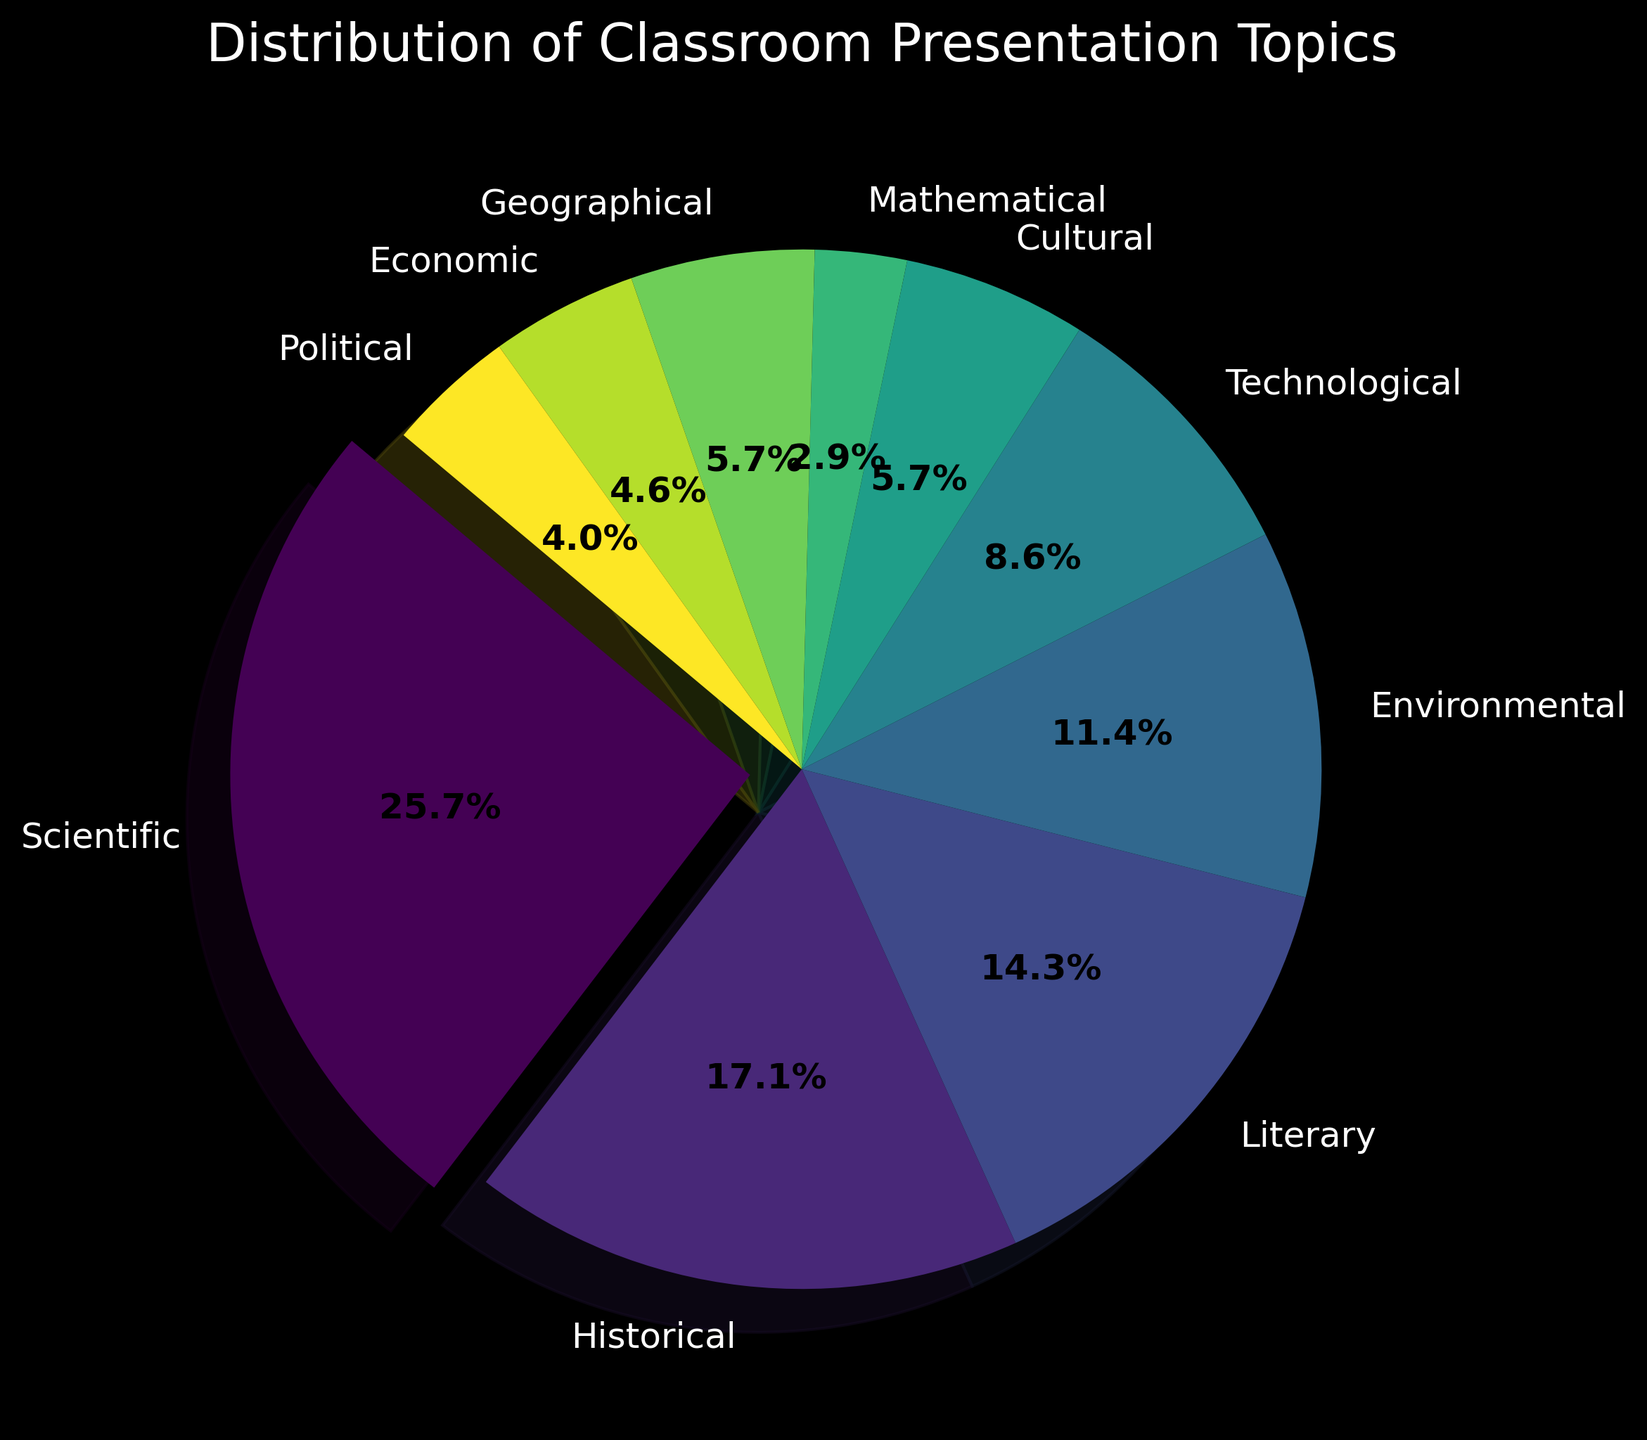What percentage of presentation topics are Scientific? The figure shows the distribution of presentation topics as a pie chart, with labels indicating the percentage. By looking at the Scientific portion of the pie chart, which is exploded for emphasis, we can see it represents 25%
Answer: 25% How does the number of Historical topics compare to Political topics? To find the answer, we compare the size of the slices representing Historical and Political topics. The Historical slice is significantly larger than the Political slice. The counts are 30 for Historical and 7 for Political.
Answer: Historical topics are more than Political topics Which topic is represented by the smallest slice? By examining the pie chart, the smallest slice can be identified visually. The slice for Mathematical topics is the smallest, with a count of 5.
Answer: Mathematical How many more Scientific topics are there compared to Environmental topics? From the figure, we know there are 45 Scientific topics and 20 Environmental topics. By subtracting the count for Environmental from that for Scientific (45 - 20), we get the difference.
Answer: 25 What is the total percentage of Cultural, Geographical, and Economic topics combined? We need to sum the percentages for Cultural, Geographical, and Economic topics from the pie chart: Cultural (5%), Geographical (5%), and Economic (4%). Adding these percentages together (5% + 5% + 4%) gives us the total.
Answer: 14% What percentage of the topics are Environmental? By looking at the pie chart segment labeled "Environmental", we can see the percentage indicated for this topic. It represents 11.1% of the total topics.
Answer: 11.1% Which topic has the second largest proportion? The pie chart segments visually indicate the proportion of each topic. The second largest segment after Scientific is Historical, with 16.7%.
Answer: Historical Compare the colors used for Literary and Technological topics. In the pie chart, each topic is represented by a distinct color. Literary topics have a shade of green, whereas Technological topics are depicted in a varying shade of purple.
Answer: Literary: green, Technological: purple What proportion of the topics is neither Scientific nor Historical? To find this, we sum the percentages of all topics (100%) and subtract the combined percentage of Scientific (25%) and Historical (16.7%). The calculation is 100% - (25% + 16.7%) = 58.3%.
Answer: 58.3% How does the count for Economic topics compare to Geographical topics? By comparing the sizes of the slices for Economic and Geographical topics, we see that the slice for Economic topics is slightly smaller. The counts are Economic (8) and Geographical (10).
Answer: Economic is less than Geographical 